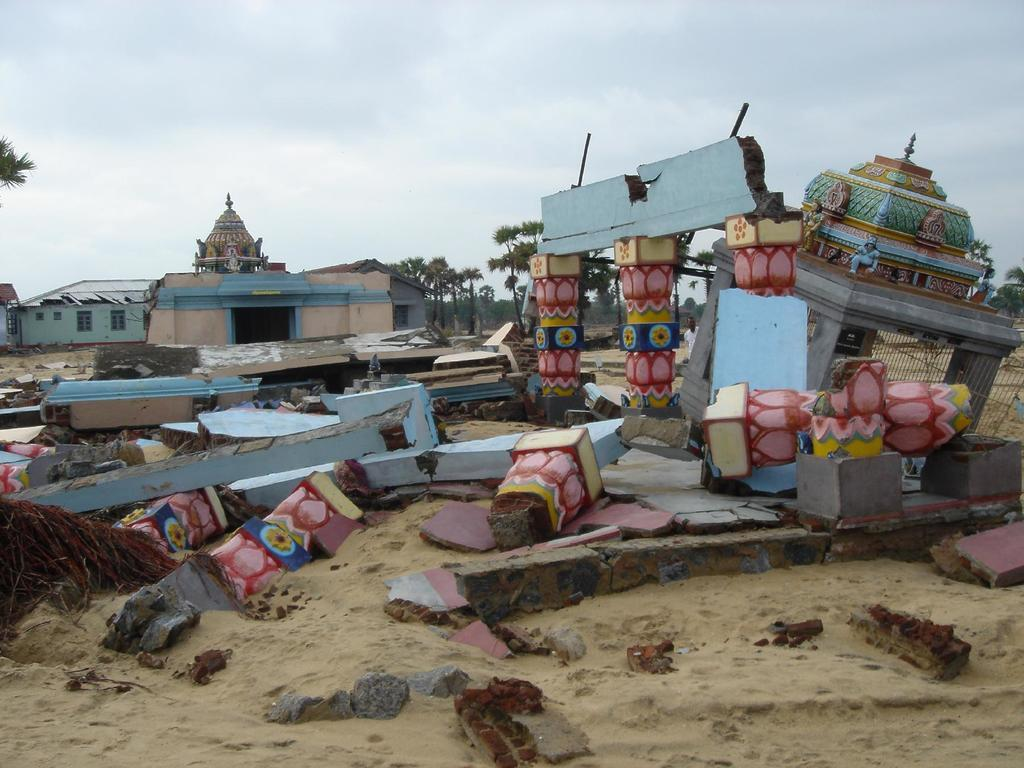What type of structure is shown in a collapsed state in the image? There is a collapsed temple in the image. What can be seen behind the temple in the image? There are houses behind the temple in the image. What type of vegetation is visible in the image? There are trees visible in the image. How would you describe the sky in the image? The sky is cloudy in the image. What flavor of ice cream is being enjoyed by the people laughing in the image? There is no ice cream or people laughing present in the image; it features a collapsed temple, houses, trees, and a cloudy sky. 